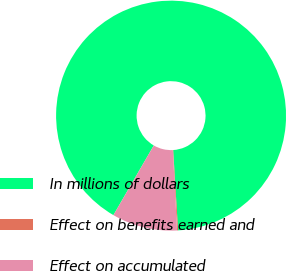Convert chart. <chart><loc_0><loc_0><loc_500><loc_500><pie_chart><fcel>In millions of dollars<fcel>Effect on benefits earned and<fcel>Effect on accumulated<nl><fcel>90.68%<fcel>0.14%<fcel>9.19%<nl></chart> 